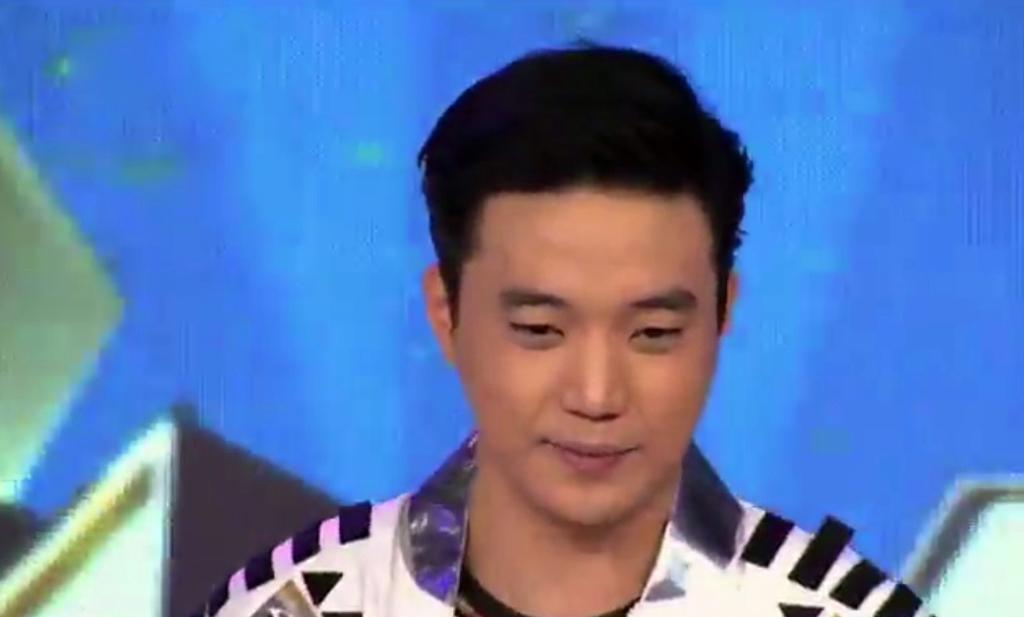Who is present in the image? There is a man in the image. What is the man wearing in the image? The man is wearing a jacket. Can you describe the jacket's color? The jacket is white and black in color. What can be seen in the background of the image? The background of the image is blue. What type of flower is the man holding in the image? There is no flower present in the image; the man is wearing a jacket. Can you describe the man's self-awareness in the image? The image does not provide any information about the man's self-awareness. Where is the kettle located in the image? There is no kettle present in the image. 